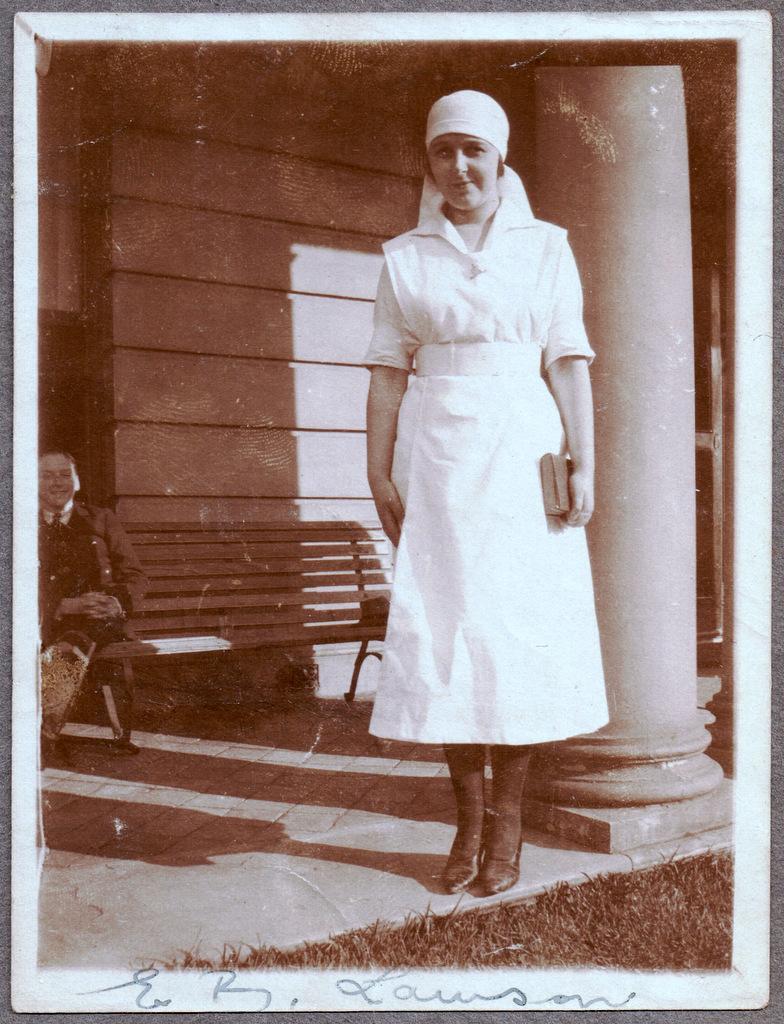Please provide a concise description of this image. This image consists of a woman wearing white dress. On the left, there is another woman sitting on a bench. At the bottom, we can see green grass. On the right, there is a pillar. In the background, there is a wall. It looks like a photograph. 